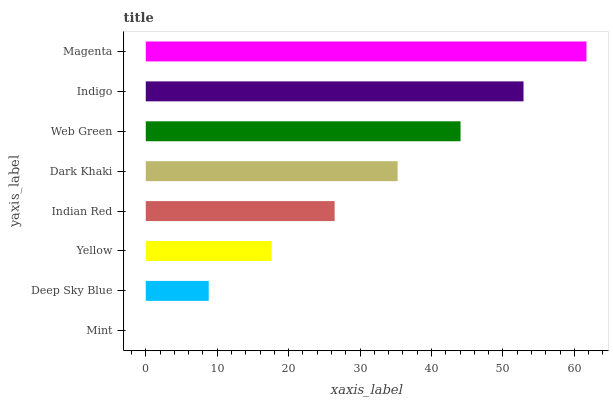Is Mint the minimum?
Answer yes or no. Yes. Is Magenta the maximum?
Answer yes or no. Yes. Is Deep Sky Blue the minimum?
Answer yes or no. No. Is Deep Sky Blue the maximum?
Answer yes or no. No. Is Deep Sky Blue greater than Mint?
Answer yes or no. Yes. Is Mint less than Deep Sky Blue?
Answer yes or no. Yes. Is Mint greater than Deep Sky Blue?
Answer yes or no. No. Is Deep Sky Blue less than Mint?
Answer yes or no. No. Is Dark Khaki the high median?
Answer yes or no. Yes. Is Indian Red the low median?
Answer yes or no. Yes. Is Indigo the high median?
Answer yes or no. No. Is Dark Khaki the low median?
Answer yes or no. No. 